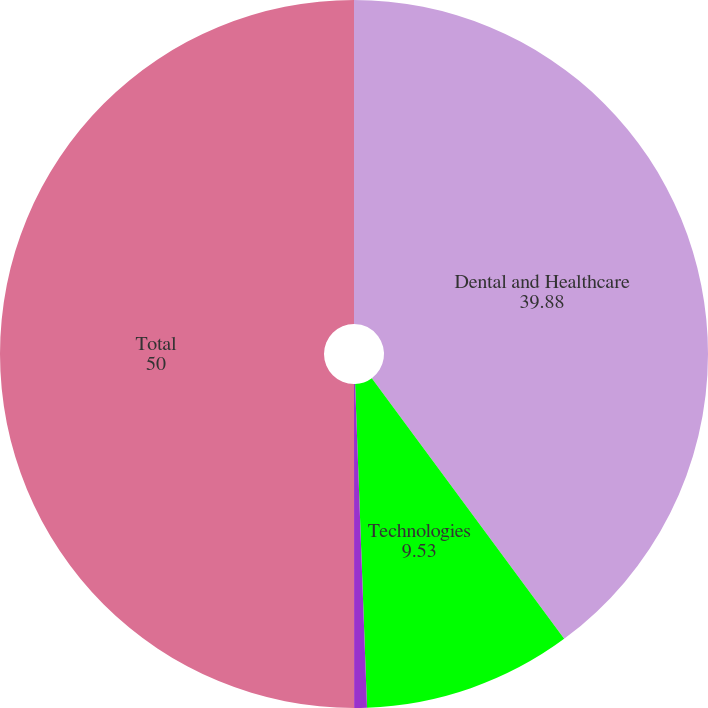<chart> <loc_0><loc_0><loc_500><loc_500><pie_chart><fcel>Dental and Healthcare<fcel>Technologies<fcel>All Other<fcel>Total<nl><fcel>39.88%<fcel>9.53%<fcel>0.58%<fcel>50.0%<nl></chart> 